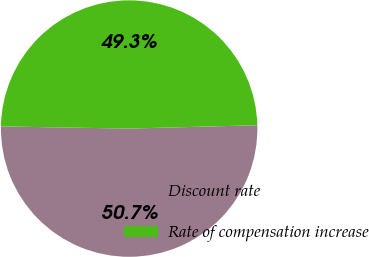Convert chart. <chart><loc_0><loc_0><loc_500><loc_500><pie_chart><fcel>Discount rate<fcel>Rate of compensation increase<nl><fcel>50.68%<fcel>49.32%<nl></chart> 